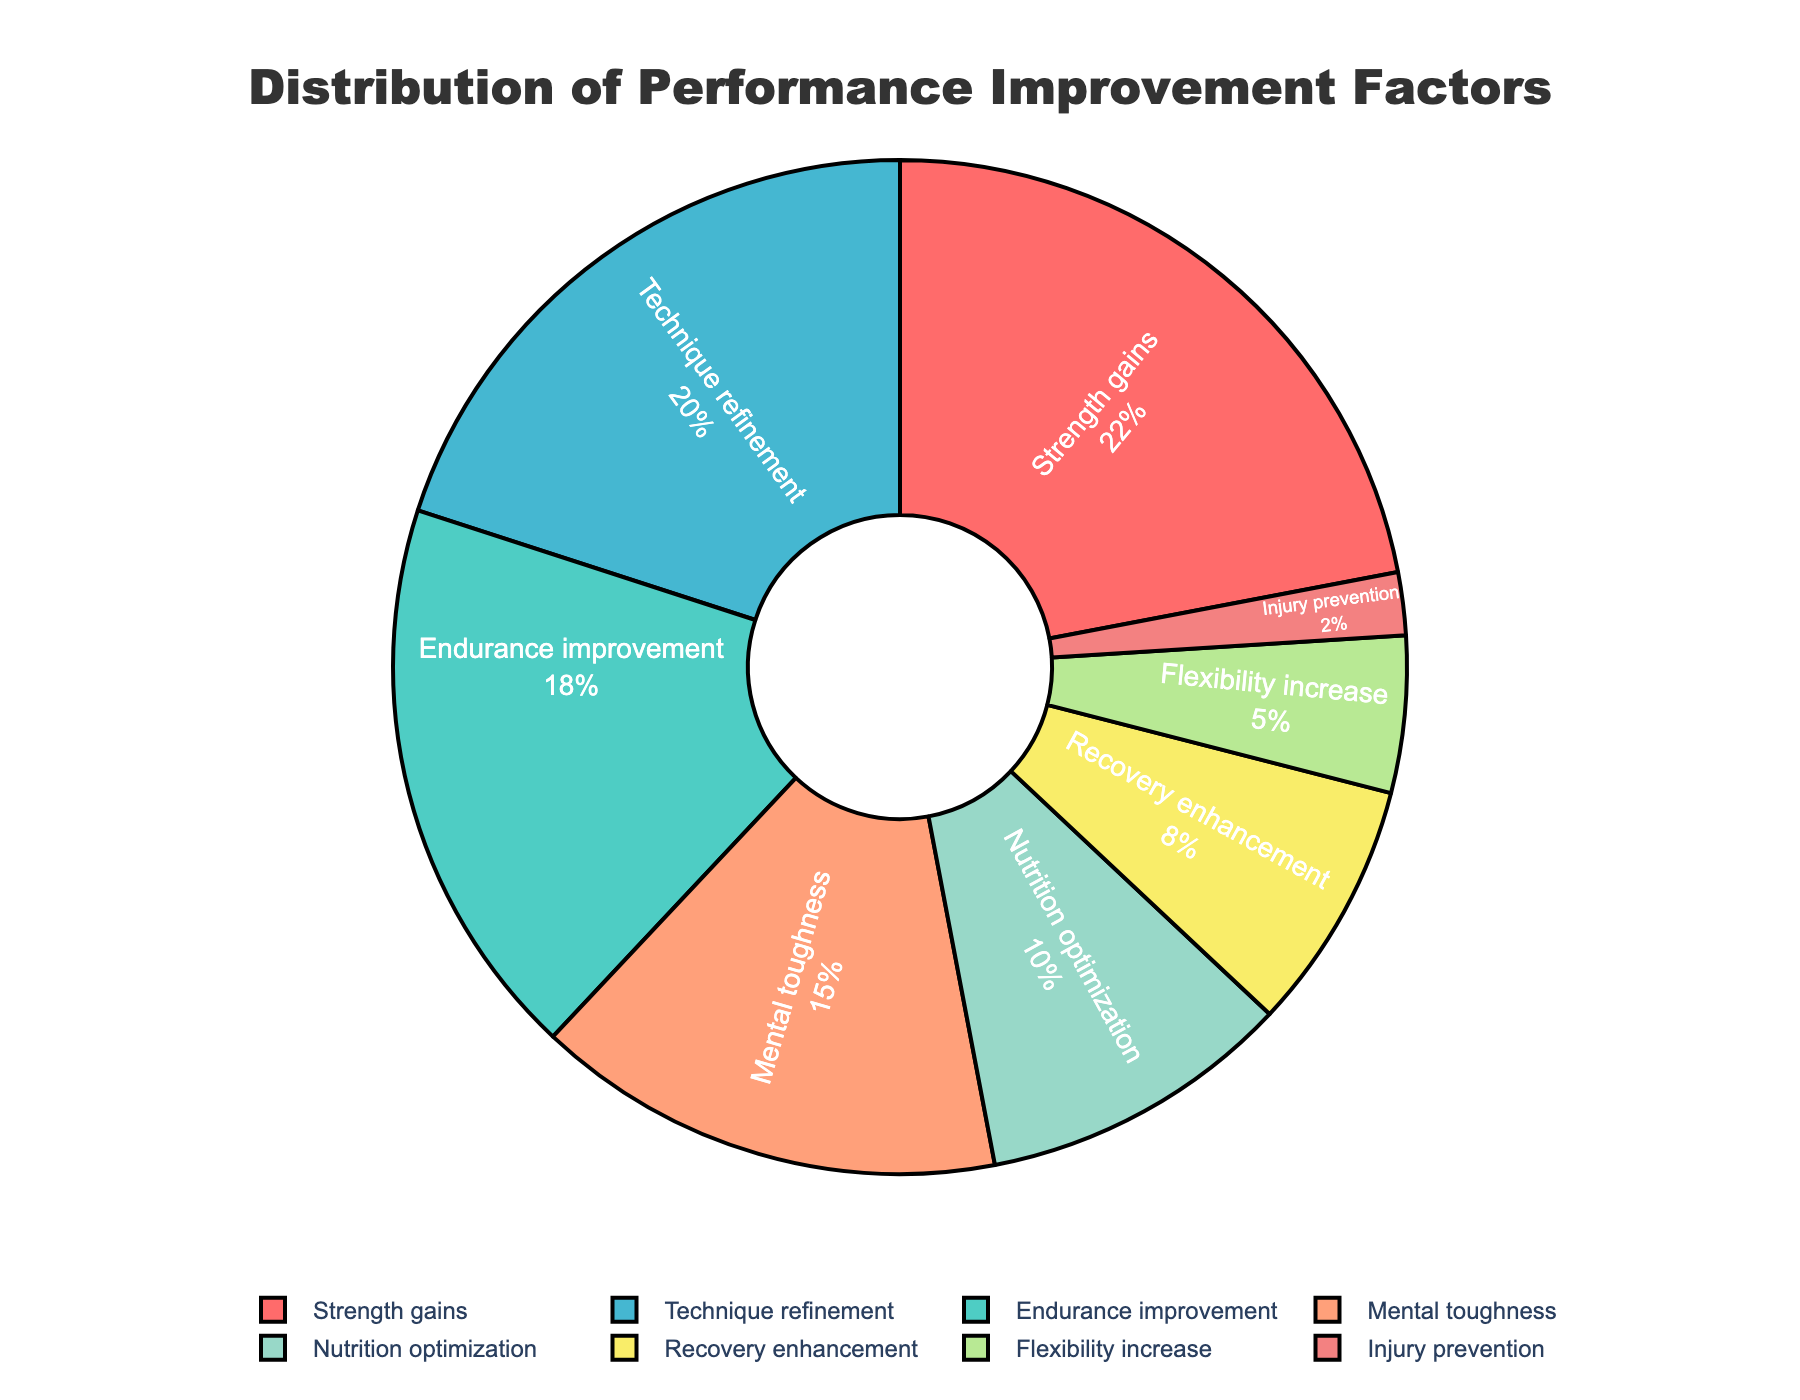Which performance improvement factor has the highest percentage? Observe the pie chart and identify the section with the largest slice. The "Strength gains" section represents the highest percentage.
Answer: Strength gains What is the combined percentage of Nutrition optimization and Recovery enhancement? Add the percentages of Nutrition optimization (10%) and Recovery enhancement (8%). The combined percentage is 10% + 8% = 18%.
Answer: 18% Which factor contributes the least to the performance improvement? Identify the smallest slice in the pie chart. The "Injury prevention" section is the smallest, with a percentage of 2%.
Answer: Injury prevention How does the percentage of Technique refinement compare to Endurance improvement? Compare the sizes of "Technique refinement" (20%) and "Endurance improvement" (18%). Technique refinement is larger than Endurance improvement.
Answer: Technique refinement is larger What is the total percentage for Endurance improvement, Flexibility increase, and Mental toughness combined? Add the percentages of Endurance improvement (18%), Flexibility increase (5%), and Mental toughness (15%). The total is 18% + 5% + 15% = 38%.
Answer: 38% Which color represents Mental toughness? Identify the color of the section labeled "Mental toughness" in the pie chart.
Answer: Light orange Is the percentage of Strength gains greater than the combined percentages of Flexibility increase and Injury prevention? Compare the percentage of Strength gains (22%) with the combined percentages of Flexibility increase (5%) and Injury prevention (2%). 5% + 2% = 7%, which is less than 22%.
Answer: Yes What is the difference in percentage between Technique refinement and Nutrition optimization? Subtract the percentage of Nutrition optimization (10%) from Technique refinement (20%). 20% - 10% = 10%.
Answer: 10% Among the factors, which one has the second smallest percentage? Identify the factors with the smallest percentages and compare. "Flexibility increase" is the second smallest with 5%.
Answer: Flexibility increase How much larger is the percentage for Strength gains than for Recovery enhancement? Subtract the percentage of Recovery enhancement (8%) from Strength gains (22%). 22% - 8% = 14%.
Answer: 14% 